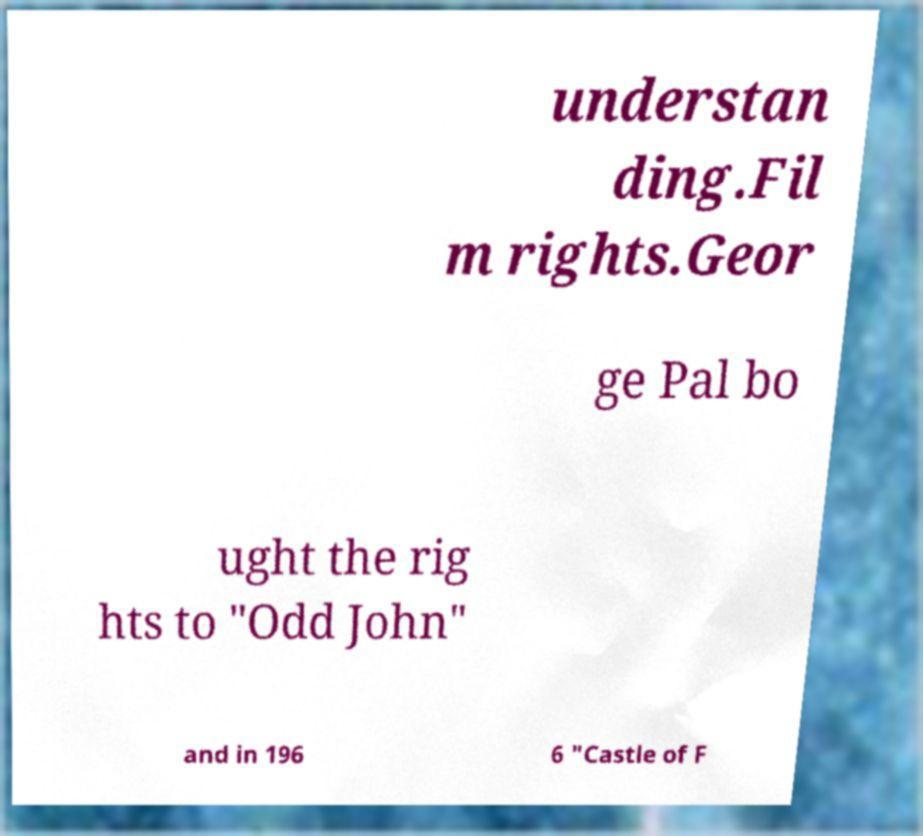Can you accurately transcribe the text from the provided image for me? understan ding.Fil m rights.Geor ge Pal bo ught the rig hts to "Odd John" and in 196 6 "Castle of F 